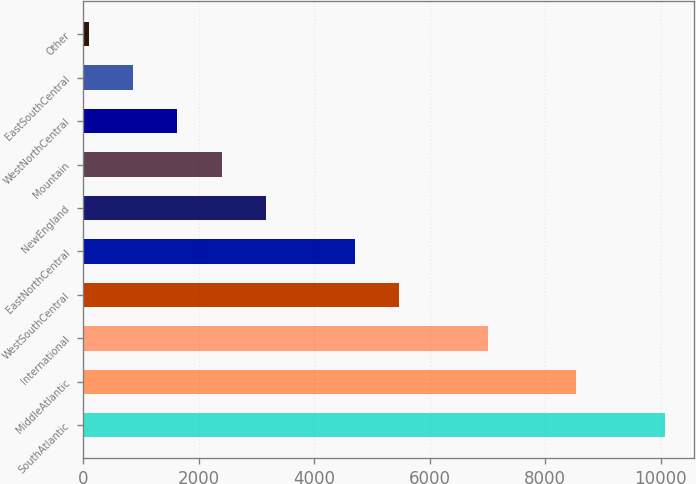Convert chart to OTSL. <chart><loc_0><loc_0><loc_500><loc_500><bar_chart><fcel>SouthAtlantic<fcel>MiddleAtlantic<fcel>International<fcel>WestSouthCentral<fcel>EastNorthCentral<fcel>NewEngland<fcel>Mountain<fcel>WestNorthCentral<fcel>EastSouthCentral<fcel>Other<nl><fcel>10073.4<fcel>8537.8<fcel>7002.2<fcel>5466.6<fcel>4698.8<fcel>3163.2<fcel>2395.4<fcel>1627.6<fcel>859.8<fcel>92<nl></chart> 